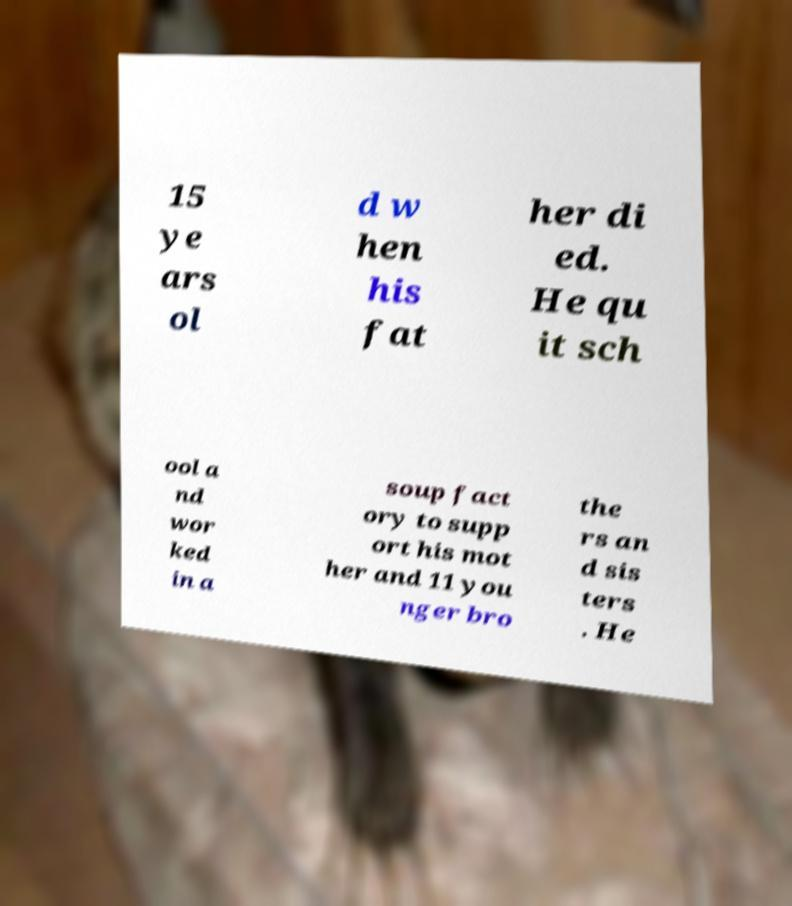There's text embedded in this image that I need extracted. Can you transcribe it verbatim? 15 ye ars ol d w hen his fat her di ed. He qu it sch ool a nd wor ked in a soup fact ory to supp ort his mot her and 11 you nger bro the rs an d sis ters . He 